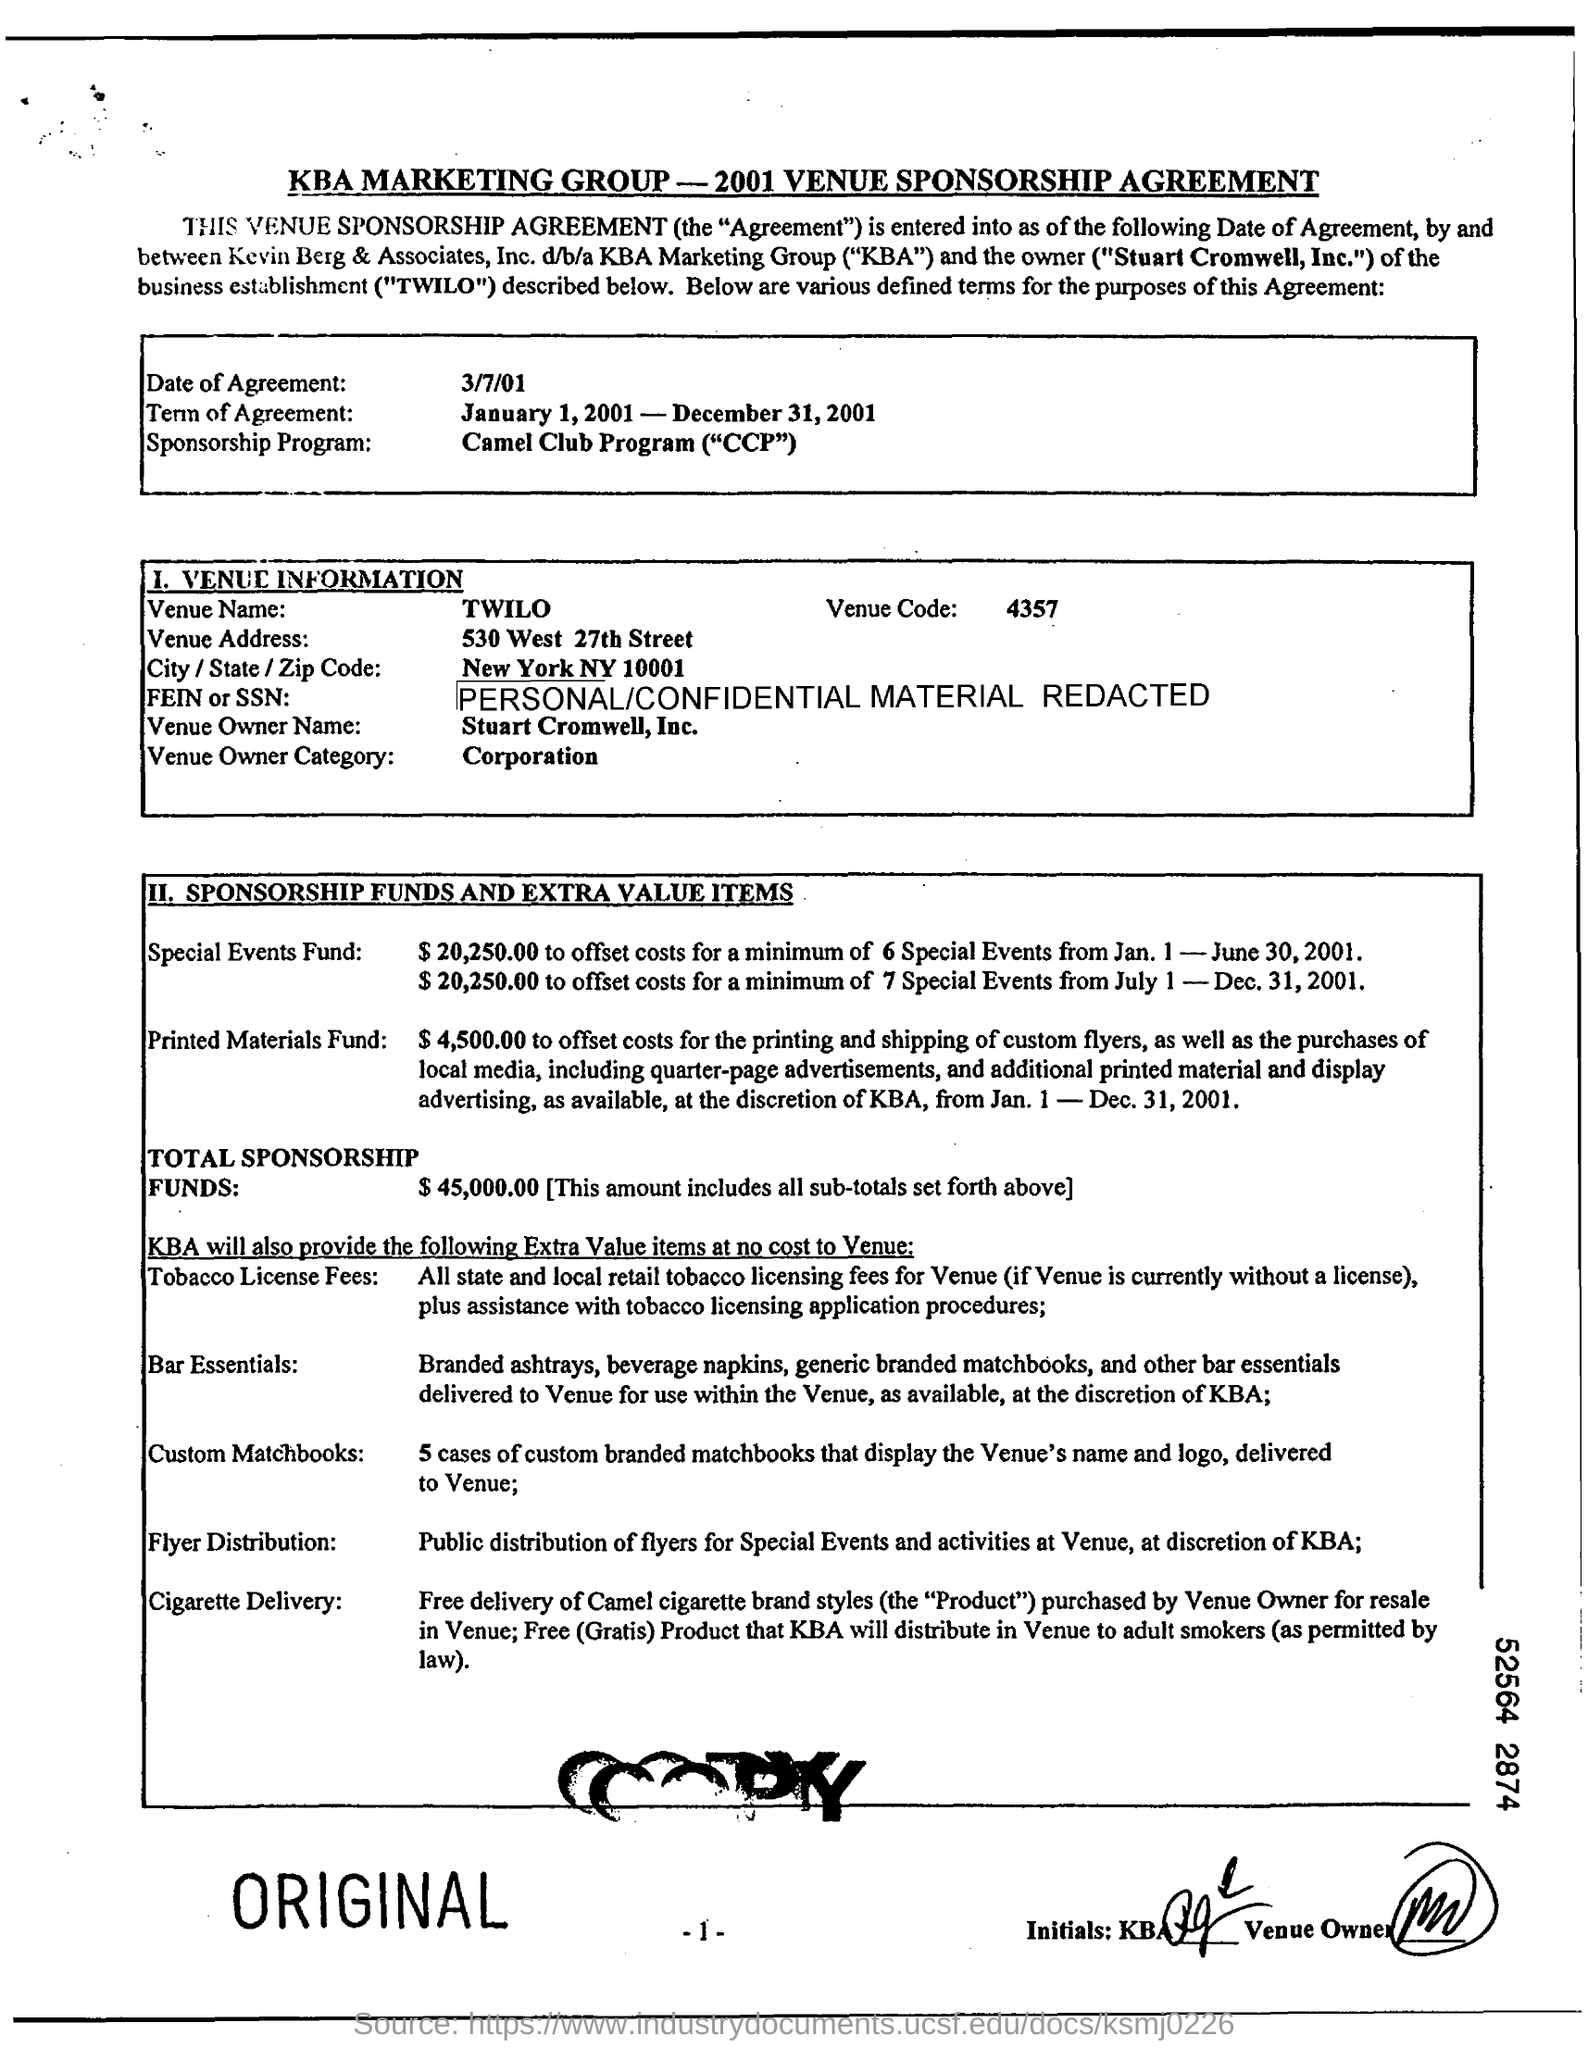What is the venue name ?
Keep it short and to the point. TWILO. What is the term of agreement ?
Give a very brief answer. January 1, 2001 - December 31, 2001. How much was the total sponsorship funds ?
Provide a succinct answer. $45,000.00. What is the venue code ?
Give a very brief answer. 4357. 